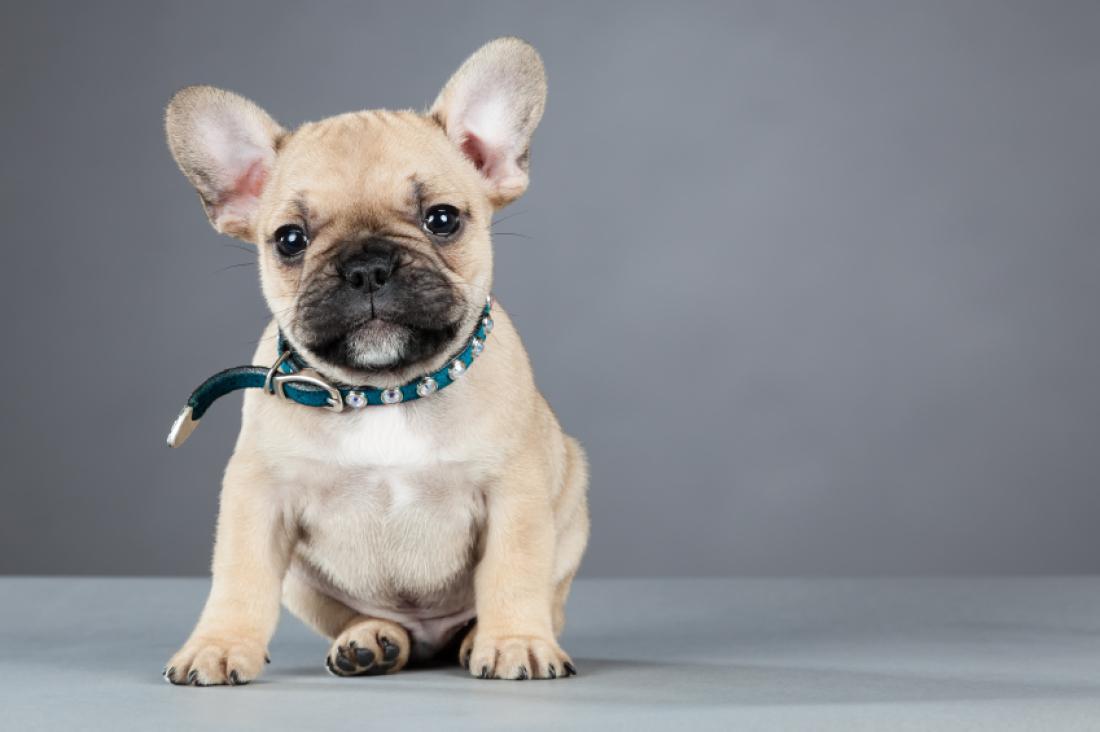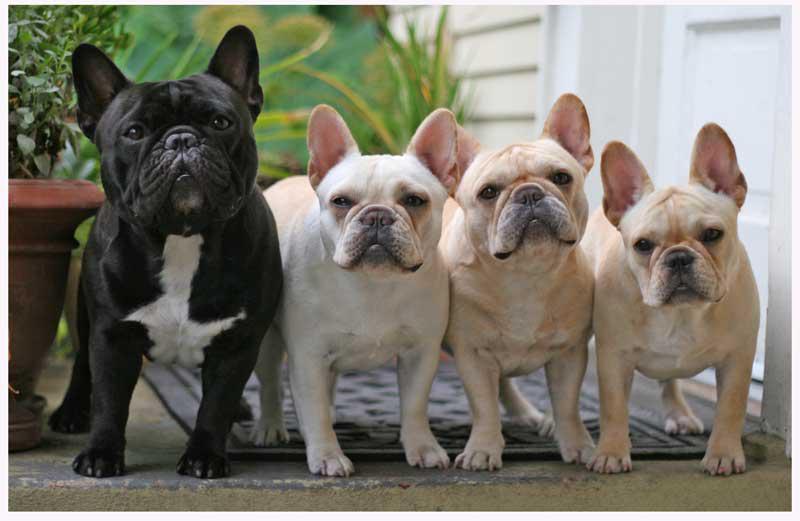The first image is the image on the left, the second image is the image on the right. Assess this claim about the two images: "There is one dog lying on its stomach in the image on the right.". Correct or not? Answer yes or no. No. 